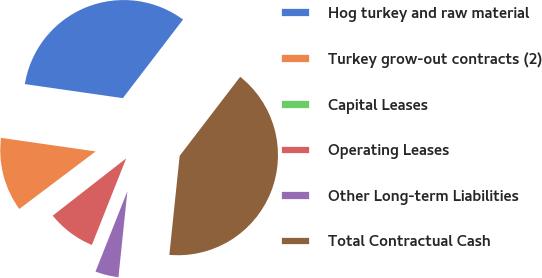Convert chart to OTSL. <chart><loc_0><loc_0><loc_500><loc_500><pie_chart><fcel>Hog turkey and raw material<fcel>Turkey grow-out contracts (2)<fcel>Capital Leases<fcel>Operating Leases<fcel>Other Long-term Liabilities<fcel>Total Contractual Cash<nl><fcel>33.13%<fcel>12.55%<fcel>0.26%<fcel>8.45%<fcel>4.36%<fcel>41.25%<nl></chart> 